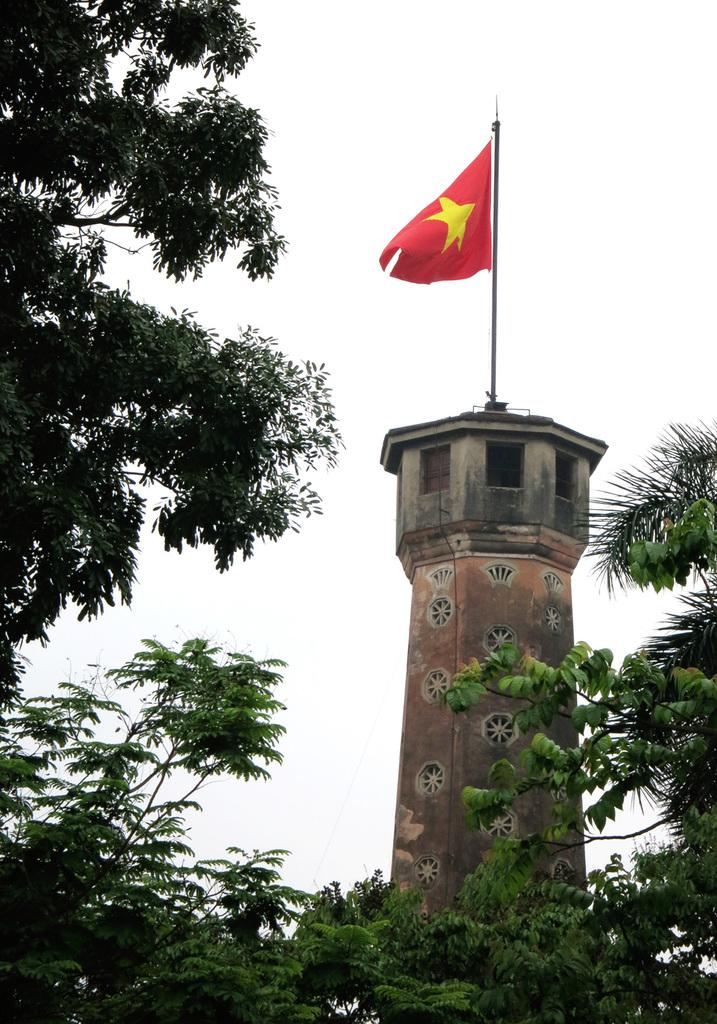What is located on the tower in the image? There is a flag on a tower in the image. What can be seen in the foreground of the image? There are trees in the foreground of the image. What is visible at the top of the image? The sky is visible at the top of the image. What type of linen is draped over the flag in the image? There is no linen present in the image; the flag is not draped over anything. How does the flag show respect in the image? The flag itself does not show respect in the image; it is simply a flag on a tower. 